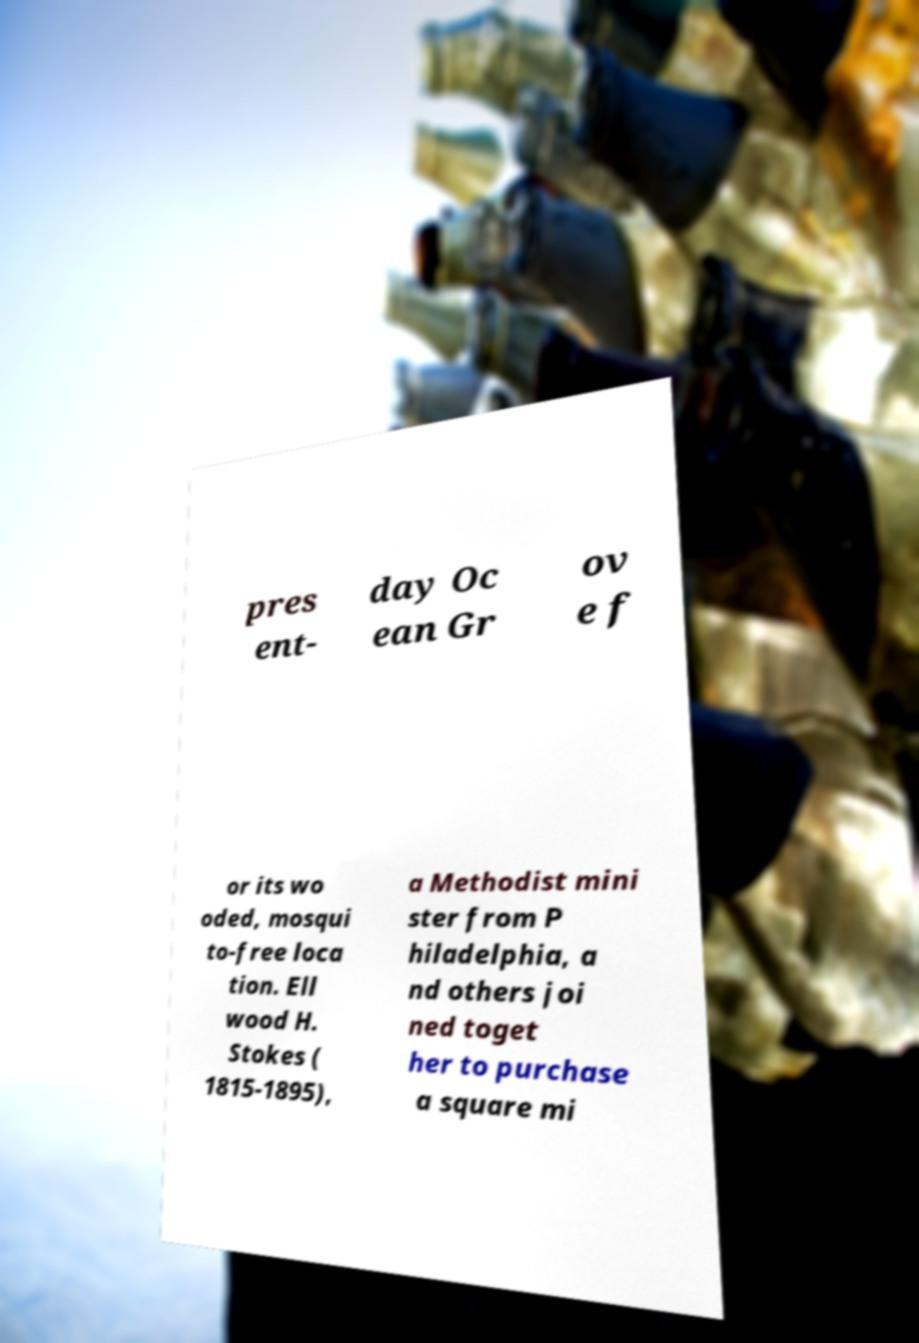There's text embedded in this image that I need extracted. Can you transcribe it verbatim? pres ent- day Oc ean Gr ov e f or its wo oded, mosqui to-free loca tion. Ell wood H. Stokes ( 1815-1895), a Methodist mini ster from P hiladelphia, a nd others joi ned toget her to purchase a square mi 